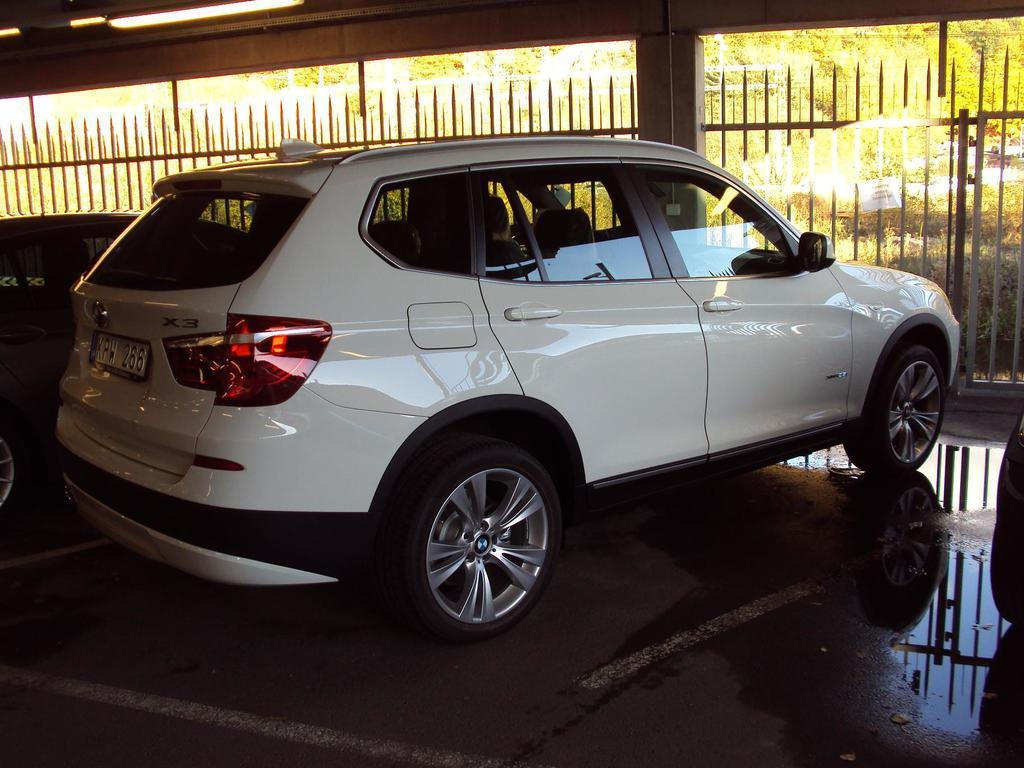How many vehicles can be seen on the path in the image? There are three vehicles on the path in the image. What can be seen in the background of the image? In the background, there are iron grills, plants, trees, and lights. Can you describe the type of plants in the background? The provided facts do not specify the type of plants in the background. What type of humor is being displayed by the word in the image? There is no word present in the image, so it is not possible to determine if any humor is being displayed. 